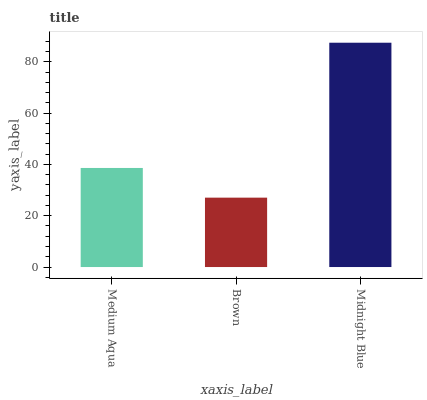Is Brown the minimum?
Answer yes or no. Yes. Is Midnight Blue the maximum?
Answer yes or no. Yes. Is Midnight Blue the minimum?
Answer yes or no. No. Is Brown the maximum?
Answer yes or no. No. Is Midnight Blue greater than Brown?
Answer yes or no. Yes. Is Brown less than Midnight Blue?
Answer yes or no. Yes. Is Brown greater than Midnight Blue?
Answer yes or no. No. Is Midnight Blue less than Brown?
Answer yes or no. No. Is Medium Aqua the high median?
Answer yes or no. Yes. Is Medium Aqua the low median?
Answer yes or no. Yes. Is Midnight Blue the high median?
Answer yes or no. No. Is Brown the low median?
Answer yes or no. No. 